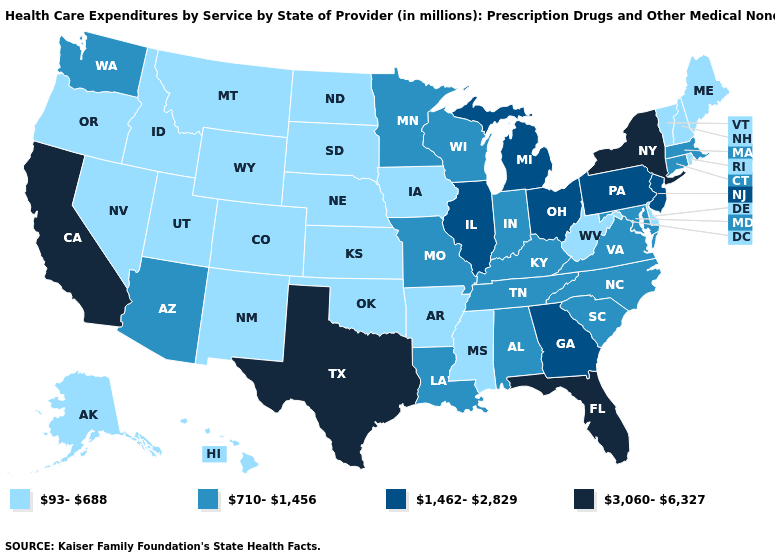Does Nebraska have a lower value than California?
Keep it brief. Yes. Name the states that have a value in the range 3,060-6,327?
Answer briefly. California, Florida, New York, Texas. Does Virginia have a higher value than Tennessee?
Keep it brief. No. What is the highest value in states that border Kansas?
Write a very short answer. 710-1,456. Name the states that have a value in the range 1,462-2,829?
Write a very short answer. Georgia, Illinois, Michigan, New Jersey, Ohio, Pennsylvania. Does the first symbol in the legend represent the smallest category?
Concise answer only. Yes. Which states have the lowest value in the Northeast?
Write a very short answer. Maine, New Hampshire, Rhode Island, Vermont. What is the value of Virginia?
Give a very brief answer. 710-1,456. What is the value of Louisiana?
Be succinct. 710-1,456. Does Texas have the highest value in the South?
Answer briefly. Yes. How many symbols are there in the legend?
Give a very brief answer. 4. What is the value of Maryland?
Short answer required. 710-1,456. What is the value of Montana?
Be succinct. 93-688. Does Wyoming have a lower value than Oregon?
Concise answer only. No. What is the highest value in the Northeast ?
Be succinct. 3,060-6,327. 